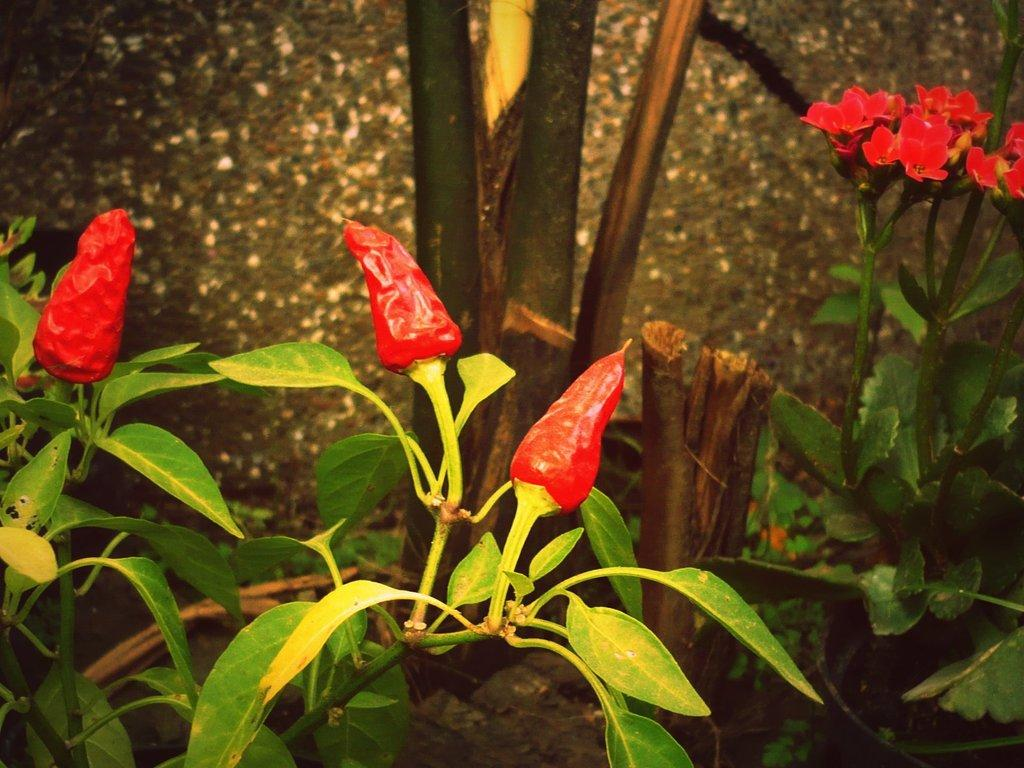What type of food is visible in the image? There are red chilies in the image. What other red objects can be seen in the image? There are red color flowers in the image. Are the flowers part of a plant? Yes, the flowers are associated with plants. What type of achievement is being celebrated in the image? There is no indication of an achievement being celebrated in the image; it features red chilies and red color flowers. 